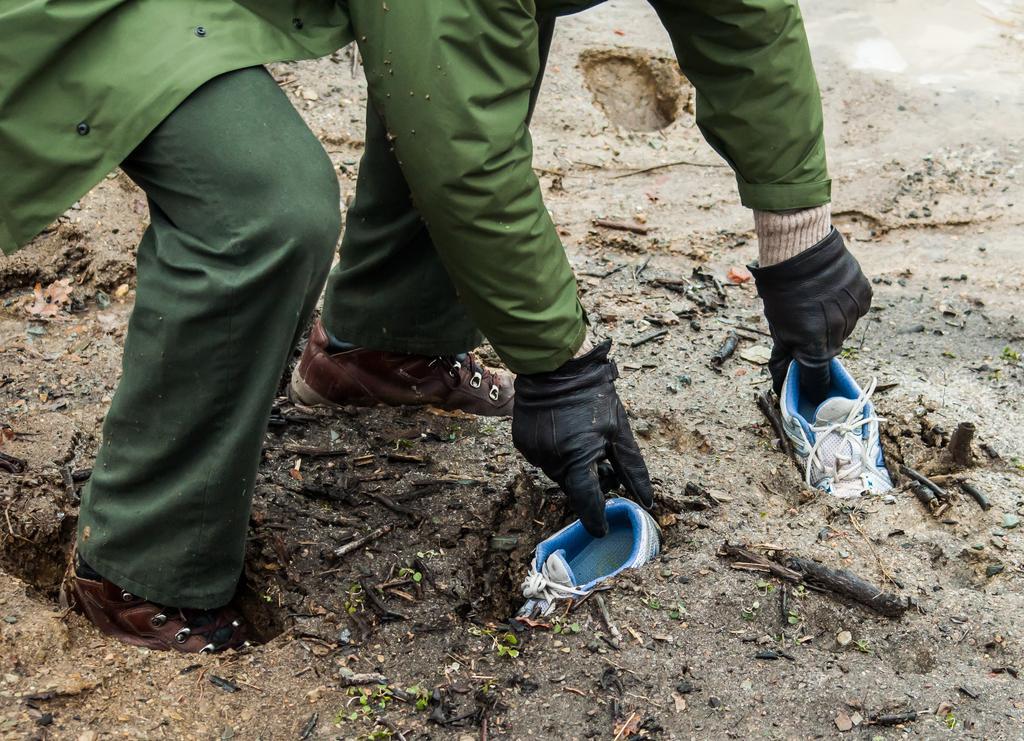In one or two sentences, can you explain what this image depicts? In this image I can see a person bending down into the mud he is holding shoes digging in the mud. 